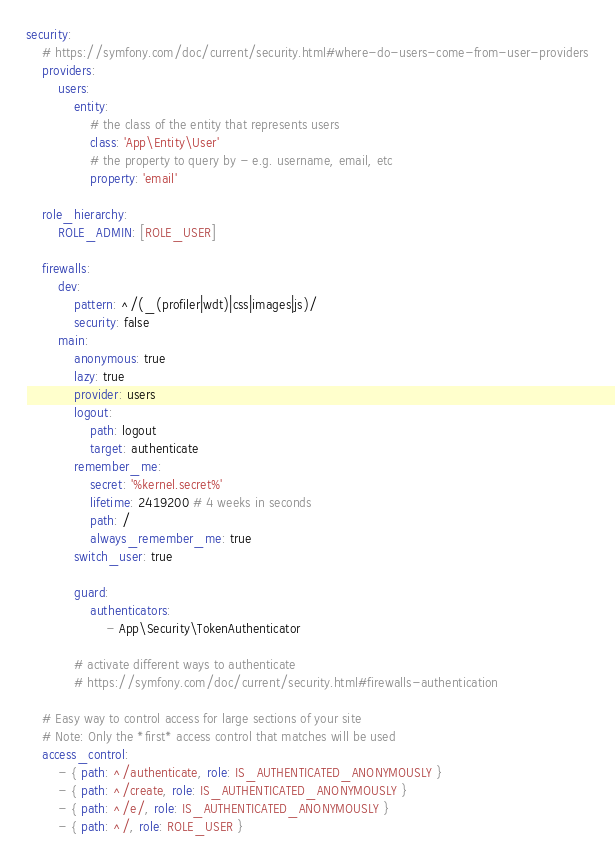<code> <loc_0><loc_0><loc_500><loc_500><_YAML_>security:
    # https://symfony.com/doc/current/security.html#where-do-users-come-from-user-providers
    providers:
        users:
            entity:
                # the class of the entity that represents users
                class: 'App\Entity\User'
                # the property to query by - e.g. username, email, etc
                property: 'email'

    role_hierarchy:
        ROLE_ADMIN: [ROLE_USER]

    firewalls:
        dev:
            pattern: ^/(_(profiler|wdt)|css|images|js)/
            security: false
        main:
            anonymous: true
            lazy: true
            provider: users
            logout:
                path: logout
                target: authenticate
            remember_me:
                secret: '%kernel.secret%'
                lifetime: 2419200 # 4 weeks in seconds
                path: /
                always_remember_me: true
            switch_user: true

            guard:
                authenticators:
                    - App\Security\TokenAuthenticator

            # activate different ways to authenticate
            # https://symfony.com/doc/current/security.html#firewalls-authentication

    # Easy way to control access for large sections of your site
    # Note: Only the *first* access control that matches will be used
    access_control:
        - { path: ^/authenticate, role: IS_AUTHENTICATED_ANONYMOUSLY }
        - { path: ^/create, role: IS_AUTHENTICATED_ANONYMOUSLY }
        - { path: ^/e/, role: IS_AUTHENTICATED_ANONYMOUSLY }
        - { path: ^/, role: ROLE_USER }
</code> 